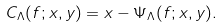Convert formula to latex. <formula><loc_0><loc_0><loc_500><loc_500>C _ { \Lambda } ( f ; x , y ) = x - \Psi _ { \Lambda } ( f ; x , y ) .</formula> 